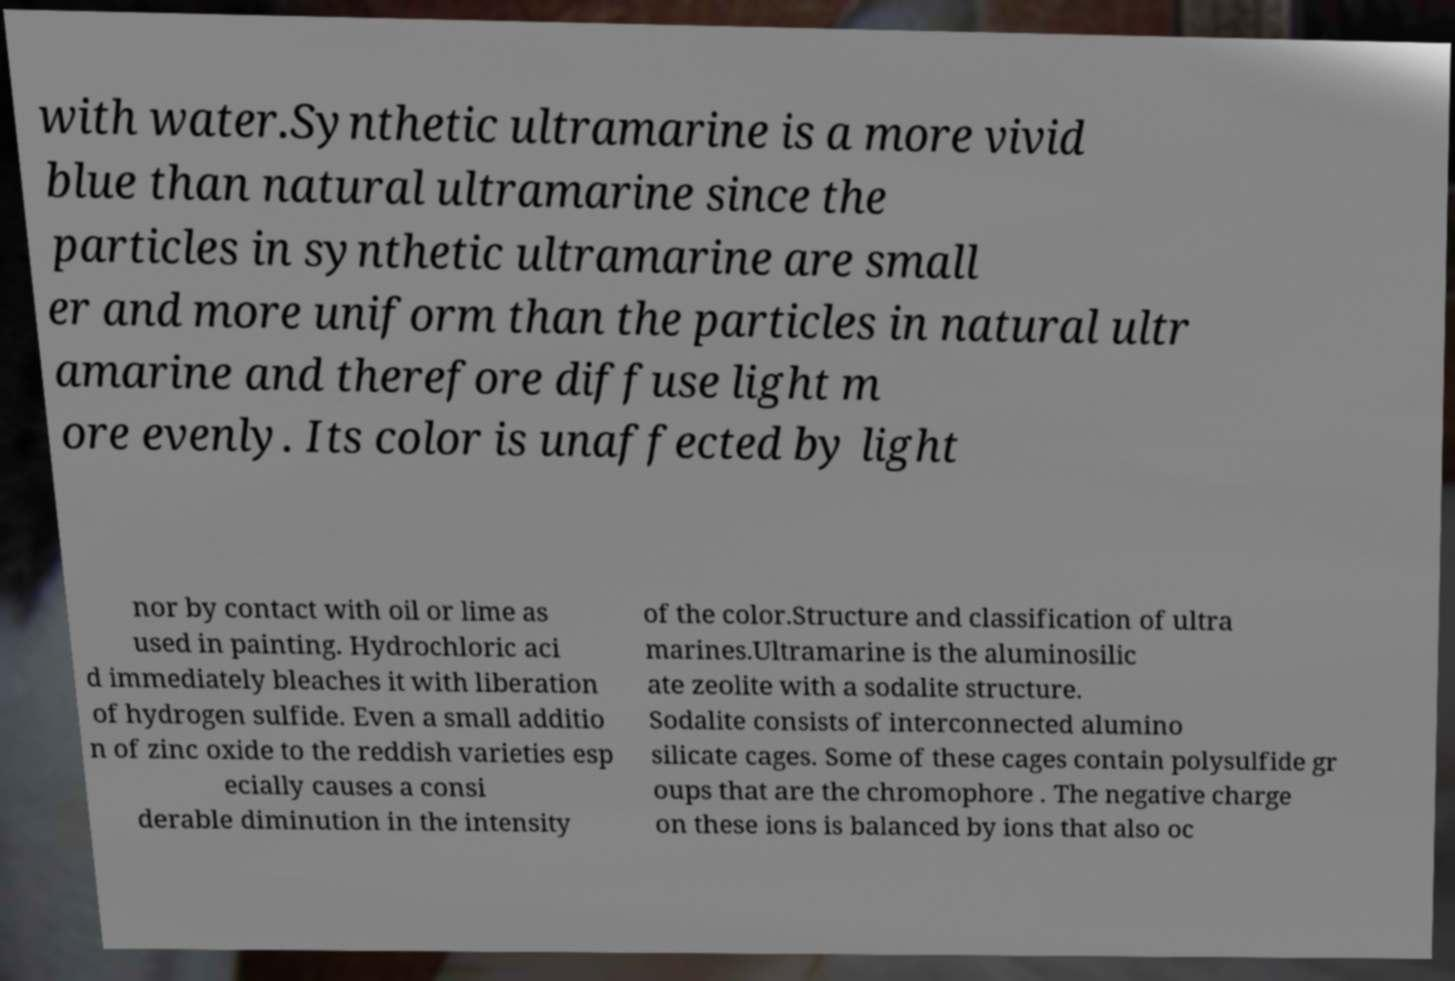For documentation purposes, I need the text within this image transcribed. Could you provide that? with water.Synthetic ultramarine is a more vivid blue than natural ultramarine since the particles in synthetic ultramarine are small er and more uniform than the particles in natural ultr amarine and therefore diffuse light m ore evenly. Its color is unaffected by light nor by contact with oil or lime as used in painting. Hydrochloric aci d immediately bleaches it with liberation of hydrogen sulfide. Even a small additio n of zinc oxide to the reddish varieties esp ecially causes a consi derable diminution in the intensity of the color.Structure and classification of ultra marines.Ultramarine is the aluminosilic ate zeolite with a sodalite structure. Sodalite consists of interconnected alumino silicate cages. Some of these cages contain polysulfide gr oups that are the chromophore . The negative charge on these ions is balanced by ions that also oc 